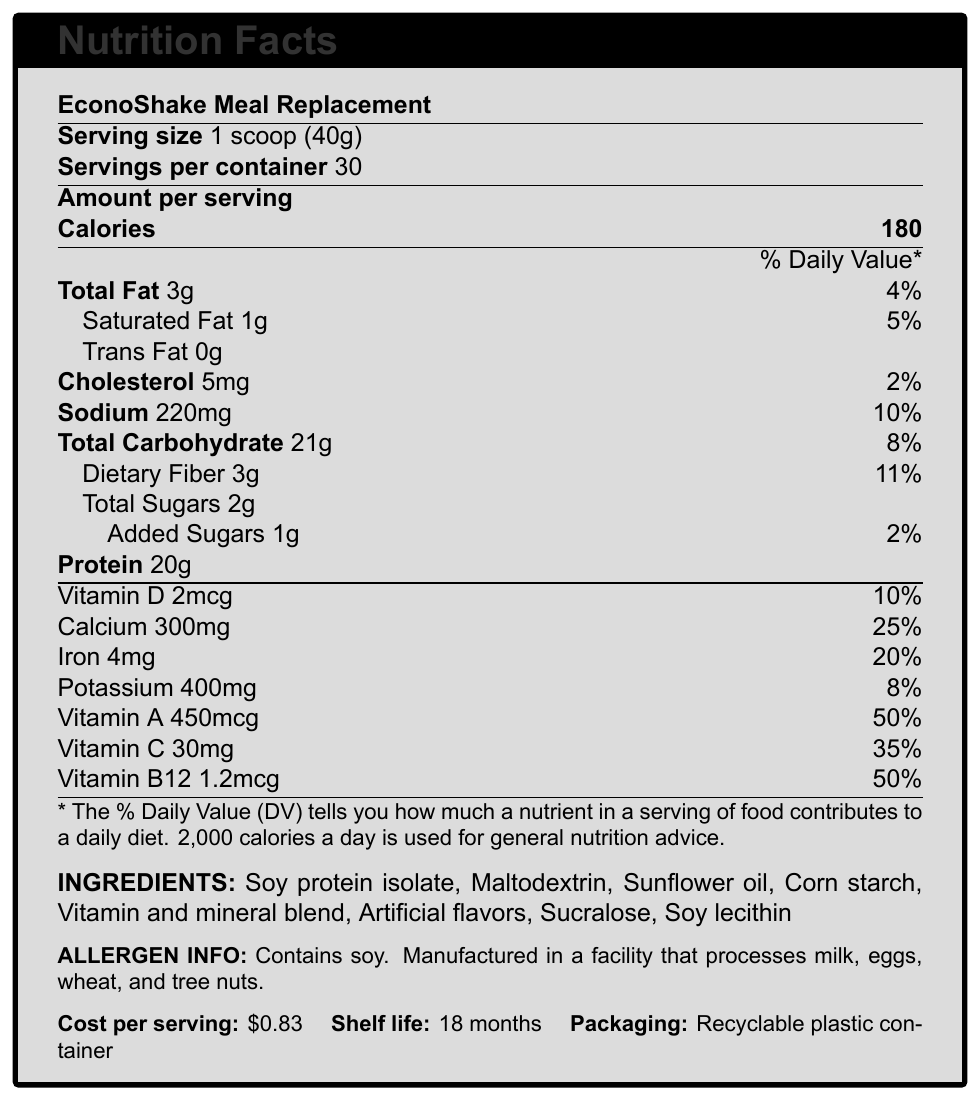what is the serving size of EconoShake Meal Replacement? The serving size is explicitly stated as "1 scoop (40g)" under the product name.
Answer: 1 scoop (40g) how many servings are there in one container? The document mentions "servings per container" as 30.
Answer: 30 how much dietary fiber is in one serving? According to the document, the dietary fiber per serving is listed as 3g.
Answer: 3g what is the daily value percentage for Total Fat? The Total Fat section specifies a daily value percentage of 4%.
Answer: 4% what is the amount of sodium per serving? The sodium content per serving is listed as 220mg.
Answer: 220mg how much does one serving cost? The cost per serving is provided as "$0.83" under additional information.
Answer: $0.83 what is the percentage of Daily Value for Vitamin A? A. 25% B. 50% C. 8% D. 10% The document lists the daily value percentage for Vitamin A as 50%.
Answer: B which of the following is not an ingredient in EconoShake? A. Soy protein isolate B. Corn starch C. Artificial flavors D. Whole milk The ingredients list includes all options except for "Whole milk".
Answer: D does EconoShake contain added sugars? The document specifically lists "Added Sugars 1g" as part of the nutritional information.
Answer: Yes summarize the main idea of the document. The document is a comprehensive Nutrition Facts Label for EconoShake Meal Replacement showing its caloric content, nutritional values, ingredients, cost, and other relevant information.
Answer: The document provides detailed nutritional information for a budget-friendly meal replacement shake called EconoShake Meal Replacement. It highlights various nutritional elements, cost per serving, shelf life, ingredients, allergen information, target demographic, and distribution channels. what is the facility's allergen processing note? The allergen information specifies: "Contains soy. Manufactured in a facility that processes milk, eggs, wheat, and tree nuts."
Answer: Contains soy. Manufactured in a facility that processes milk, eggs, wheat, and tree nuts. how many grams of protein are in each serving? The protein content per serving is listed as 20g in the document.
Answer: 20g how does EconoShake help reduce strain on local food banks according to the document? One of the marketing claims mentions "helps reduce strain on local food banks."
Answer: By being a budget-friendly meal solution. what is the shelf life of EconoShake? The document specifies the shelf life as "18 months."
Answer: 18 months is EconoShake intended for high-income individuals? The document states that the target demographic is "Low-income individuals and families."
Answer: No what is the total amount of sugar per serving? The total sugars per serving are listed as "2g."
Answer: 2g has EconoShake been criticized for promoting dependence on processed foods? One of the criticisms listed is that it may promote dependence on processed foods.
Answer: Yes where is EconoShake Meal Replacement distributed? A. High-end grocery stores B. Discount grocery stores C. Pharmacies According to the document, distribution channels include "government assistance programs, food banks, and discount grocery stores."
Answer: B how many calories are there in each serving of EconoShake? The calorie content per serving is listed as 180.
Answer: 180 does the document provide information on the environmental impact of the packaging? The document only mentions that the packaging is a recyclable plastic container but doesn't detail the environmental impact.
Answer: No is Vitamin B12 content in EconoShake high compared to other vitamins? The document mentions Vitamin B12 at 50% daily value, which is high compared to other vitamins like Vitamin D (10%) or Potassium (8%).
Answer: Yes 